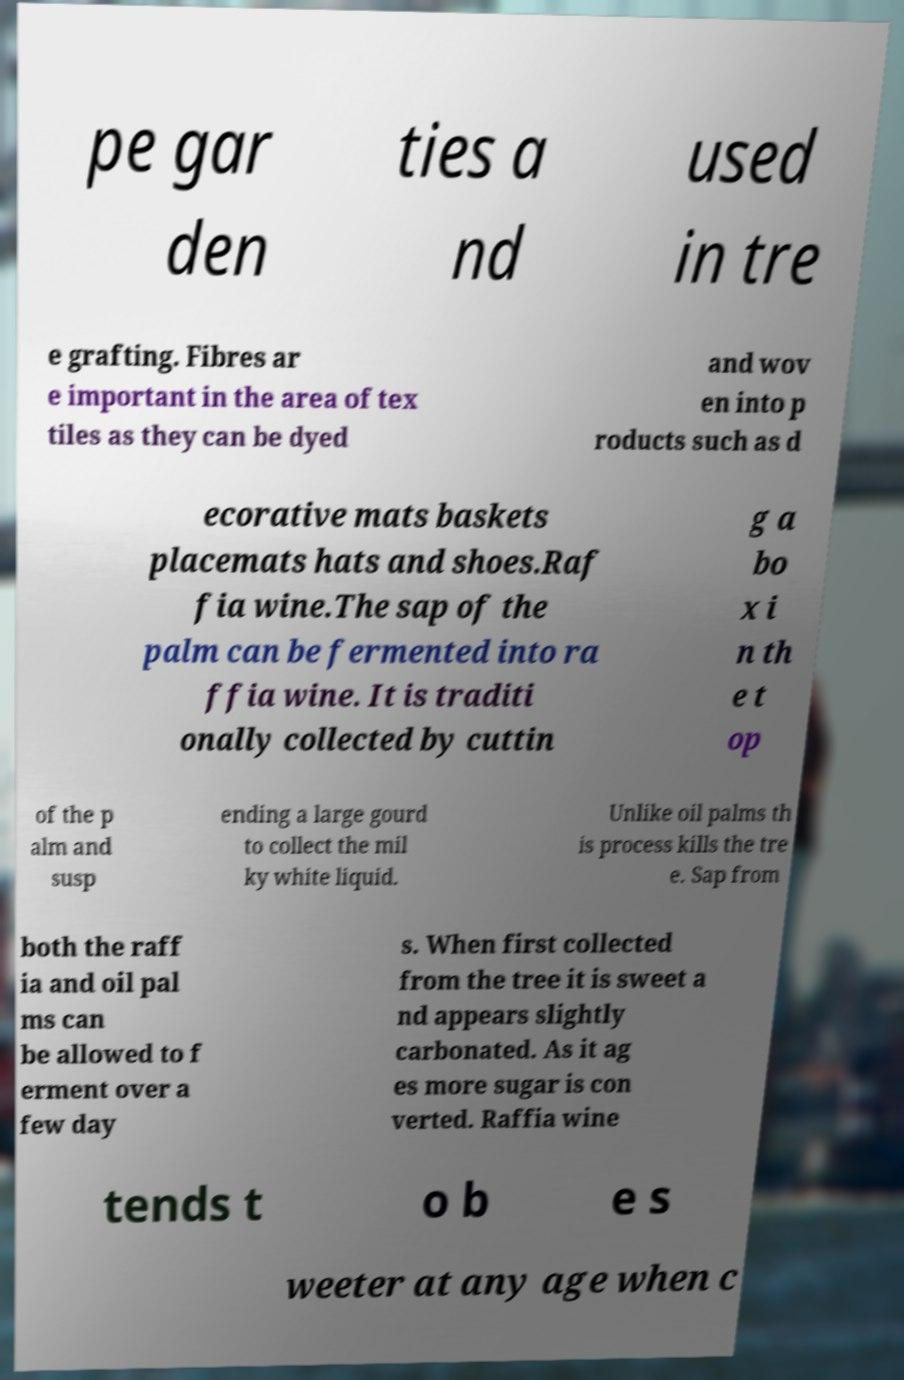I need the written content from this picture converted into text. Can you do that? pe gar den ties a nd used in tre e grafting. Fibres ar e important in the area of tex tiles as they can be dyed and wov en into p roducts such as d ecorative mats baskets placemats hats and shoes.Raf fia wine.The sap of the palm can be fermented into ra ffia wine. It is traditi onally collected by cuttin g a bo x i n th e t op of the p alm and susp ending a large gourd to collect the mil ky white liquid. Unlike oil palms th is process kills the tre e. Sap from both the raff ia and oil pal ms can be allowed to f erment over a few day s. When first collected from the tree it is sweet a nd appears slightly carbonated. As it ag es more sugar is con verted. Raffia wine tends t o b e s weeter at any age when c 